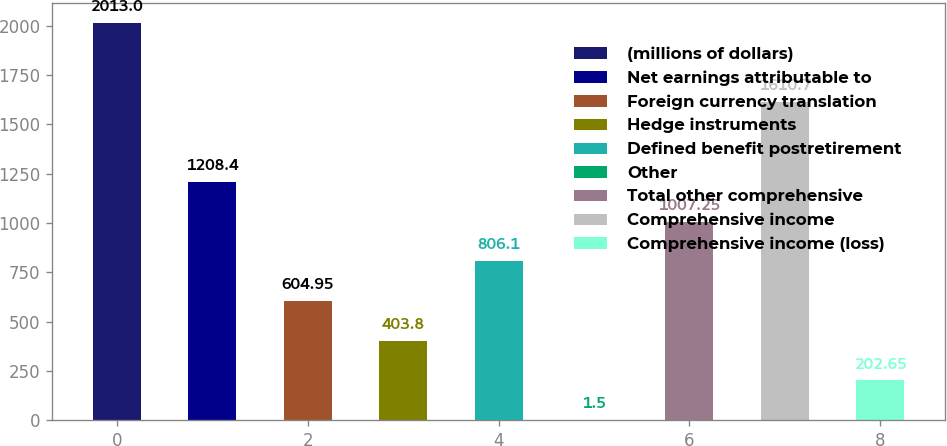Convert chart to OTSL. <chart><loc_0><loc_0><loc_500><loc_500><bar_chart><fcel>(millions of dollars)<fcel>Net earnings attributable to<fcel>Foreign currency translation<fcel>Hedge instruments<fcel>Defined benefit postretirement<fcel>Other<fcel>Total other comprehensive<fcel>Comprehensive income<fcel>Comprehensive income (loss)<nl><fcel>2013<fcel>1208.4<fcel>604.95<fcel>403.8<fcel>806.1<fcel>1.5<fcel>1007.25<fcel>1610.7<fcel>202.65<nl></chart> 